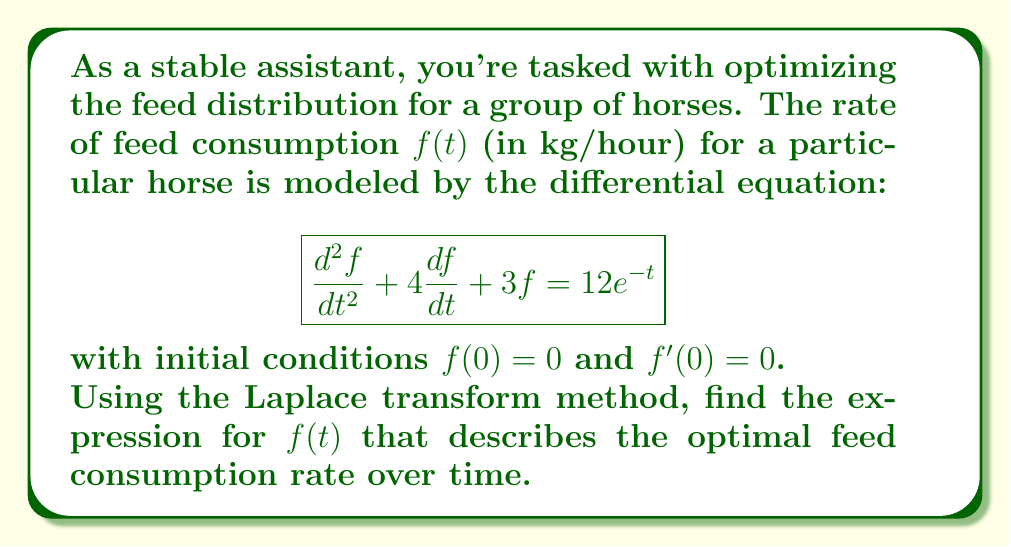Can you answer this question? Let's solve this step-by-step using the Laplace transform method:

1) Take the Laplace transform of both sides of the equation:
   $$\mathcal{L}\{\frac{d^2f}{dt^2} + 4\frac{df}{dt} + 3f\} = \mathcal{L}\{12e^{-t}\}$$

2) Using Laplace transform properties:
   $$[s^2F(s) - sf(0) - f'(0)] + 4[sF(s) - f(0)] + 3F(s) = \frac{12}{s+1}$$

3) Substitute the initial conditions $f(0) = 0$ and $f'(0) = 0$:
   $$s^2F(s) + 4sF(s) + 3F(s) = \frac{12}{s+1}$$

4) Factor out $F(s)$:
   $$F(s)(s^2 + 4s + 3) = \frac{12}{s+1}$$

5) Solve for $F(s)$:
   $$F(s) = \frac{12}{(s+1)(s^2 + 4s + 3)}$$

6) Decompose into partial fractions:
   $$F(s) = \frac{A}{s+1} + \frac{Bs+C}{s^2 + 4s + 3}$$

7) Solve for A, B, and C:
   $$A = 4, B = -4, C = -4$$

8) Rewrite $F(s)$:
   $$F(s) = \frac{4}{s+1} - \frac{4s+4}{s^2 + 4s + 3}$$

9) Take the inverse Laplace transform:
   $$f(t) = 4e^{-t} - 4e^{-2t}(1 + t)$$

This is the expression for the optimal feed consumption rate over time.
Answer: $f(t) = 4e^{-t} - 4e^{-2t}(1 + t)$ 